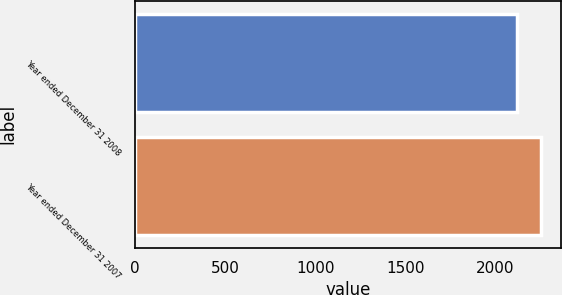Convert chart to OTSL. <chart><loc_0><loc_0><loc_500><loc_500><bar_chart><fcel>Year ended December 31 2008<fcel>Year ended December 31 2007<nl><fcel>2120<fcel>2254<nl></chart> 